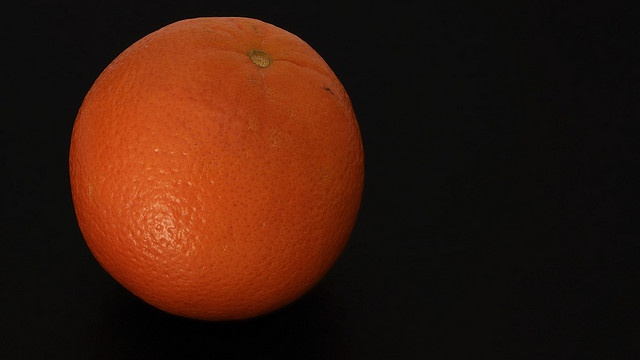Describe the objects in this image and their specific colors. I can see a orange in black, brown, red, and maroon tones in this image. 